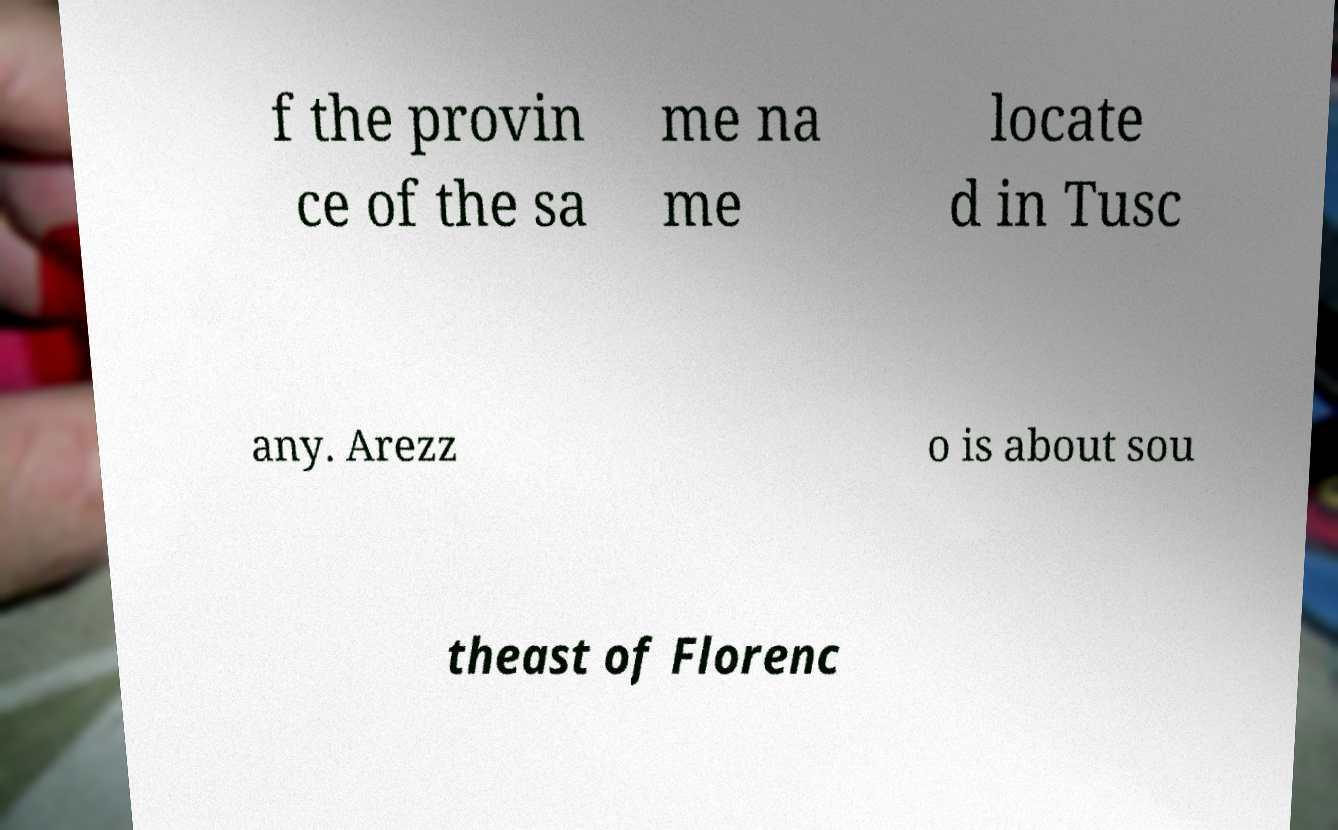Please read and relay the text visible in this image. What does it say? f the provin ce of the sa me na me locate d in Tusc any. Arezz o is about sou theast of Florenc 